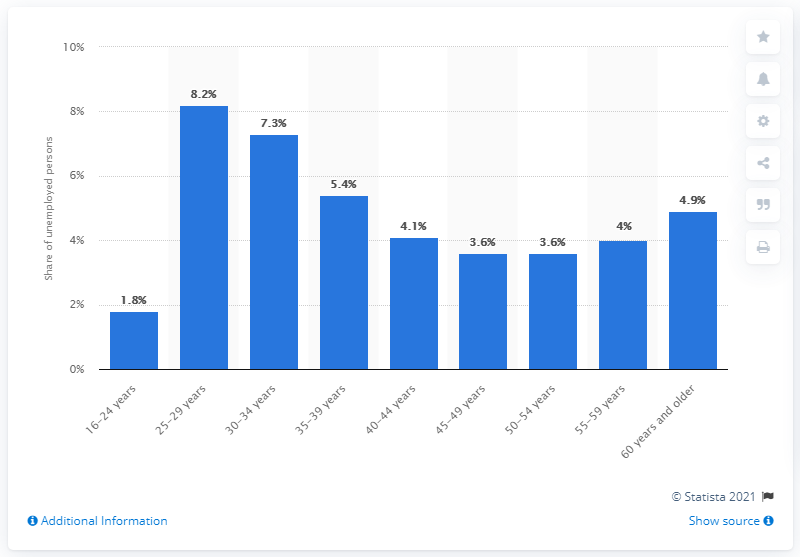Highlight a few significant elements in this photo. According to the data, the unemployment rate among the elderly was 4.9%. 